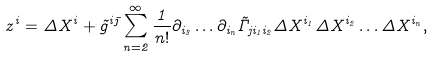<formula> <loc_0><loc_0><loc_500><loc_500>z ^ { i } = \Delta X ^ { i } + \tilde { g } ^ { i \bar { \jmath } } \sum _ { n = 2 } ^ { \infty } \frac { 1 } { n ! } \partial _ { i _ { 3 } } \dots \partial _ { i _ { n } } \tilde { \Gamma } _ { j i _ { 1 } i _ { 2 } } \Delta X ^ { i _ { 1 } } \Delta X ^ { i _ { 2 } } \dots \Delta X ^ { i _ { n } } ,</formula> 